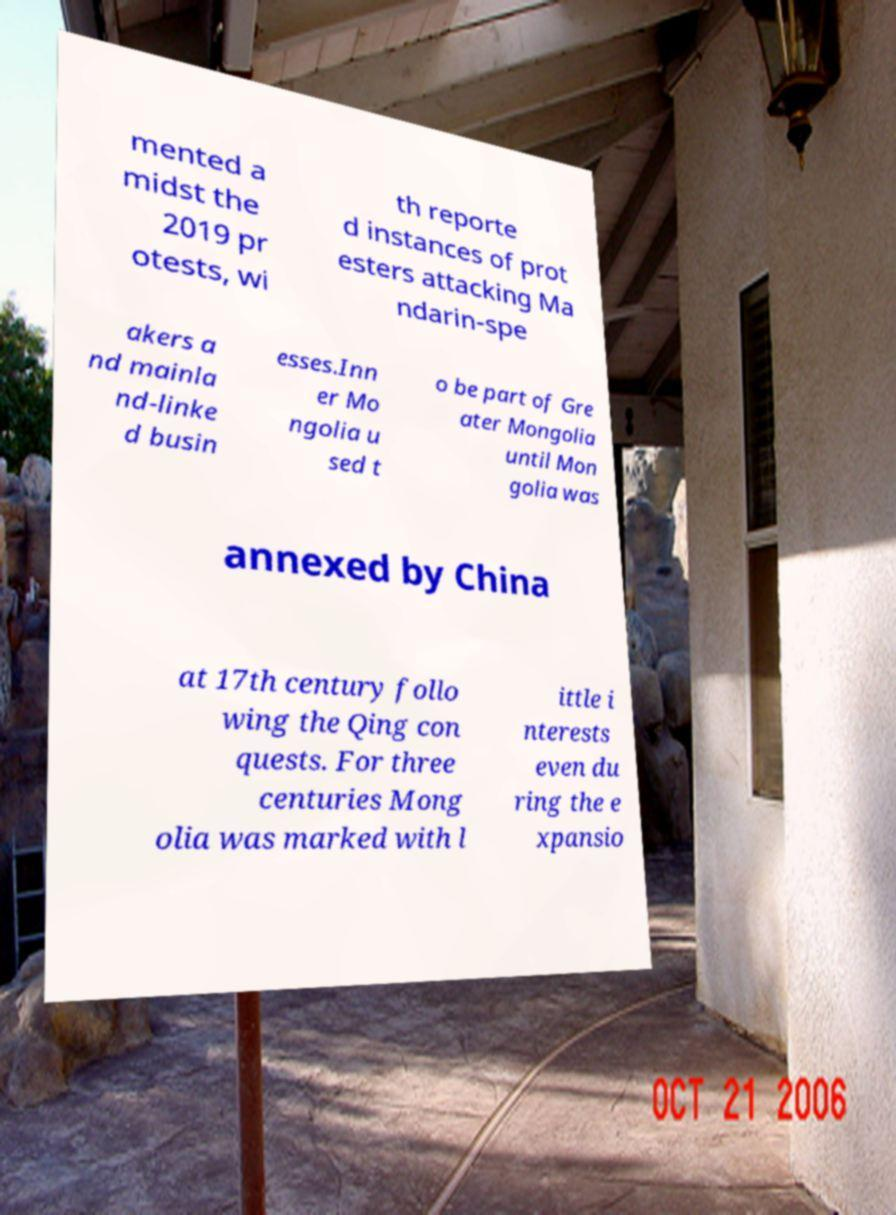What messages or text are displayed in this image? I need them in a readable, typed format. mented a midst the 2019 pr otests, wi th reporte d instances of prot esters attacking Ma ndarin-spe akers a nd mainla nd-linke d busin esses.Inn er Mo ngolia u sed t o be part of Gre ater Mongolia until Mon golia was annexed by China at 17th century follo wing the Qing con quests. For three centuries Mong olia was marked with l ittle i nterests even du ring the e xpansio 